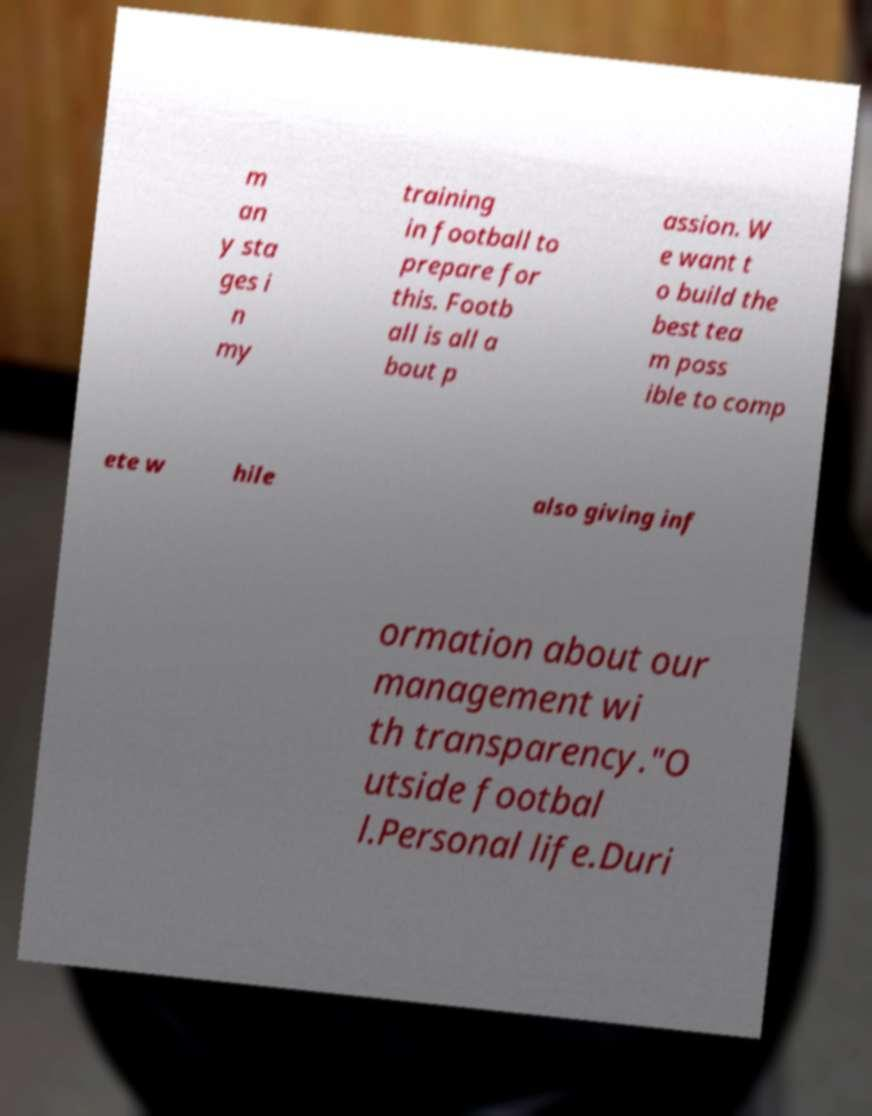Please read and relay the text visible in this image. What does it say? m an y sta ges i n my training in football to prepare for this. Footb all is all a bout p assion. W e want t o build the best tea m poss ible to comp ete w hile also giving inf ormation about our management wi th transparency."O utside footbal l.Personal life.Duri 